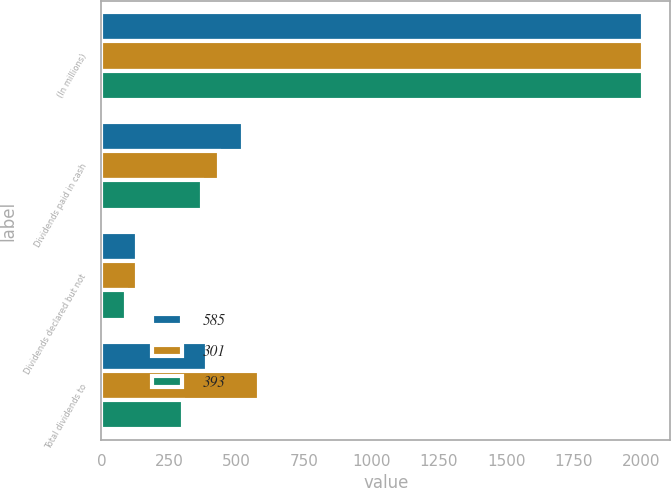Convert chart. <chart><loc_0><loc_0><loc_500><loc_500><stacked_bar_chart><ecel><fcel>(In millions)<fcel>Dividends paid in cash<fcel>Dividends declared but not<fcel>Total dividends to<nl><fcel>585<fcel>2009<fcel>524<fcel>131<fcel>393<nl><fcel>301<fcel>2008<fcel>434<fcel>131<fcel>585<nl><fcel>393<fcel>2007<fcel>373<fcel>91<fcel>301<nl></chart> 